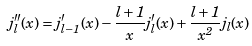<formula> <loc_0><loc_0><loc_500><loc_500>j _ { l } ^ { \prime \prime } ( x ) = j _ { l - 1 } ^ { \prime } ( x ) - \frac { l + 1 } { x } j _ { l } ^ { \prime } ( x ) + \frac { l + 1 } { x ^ { 2 } } j _ { l } ( x )</formula> 